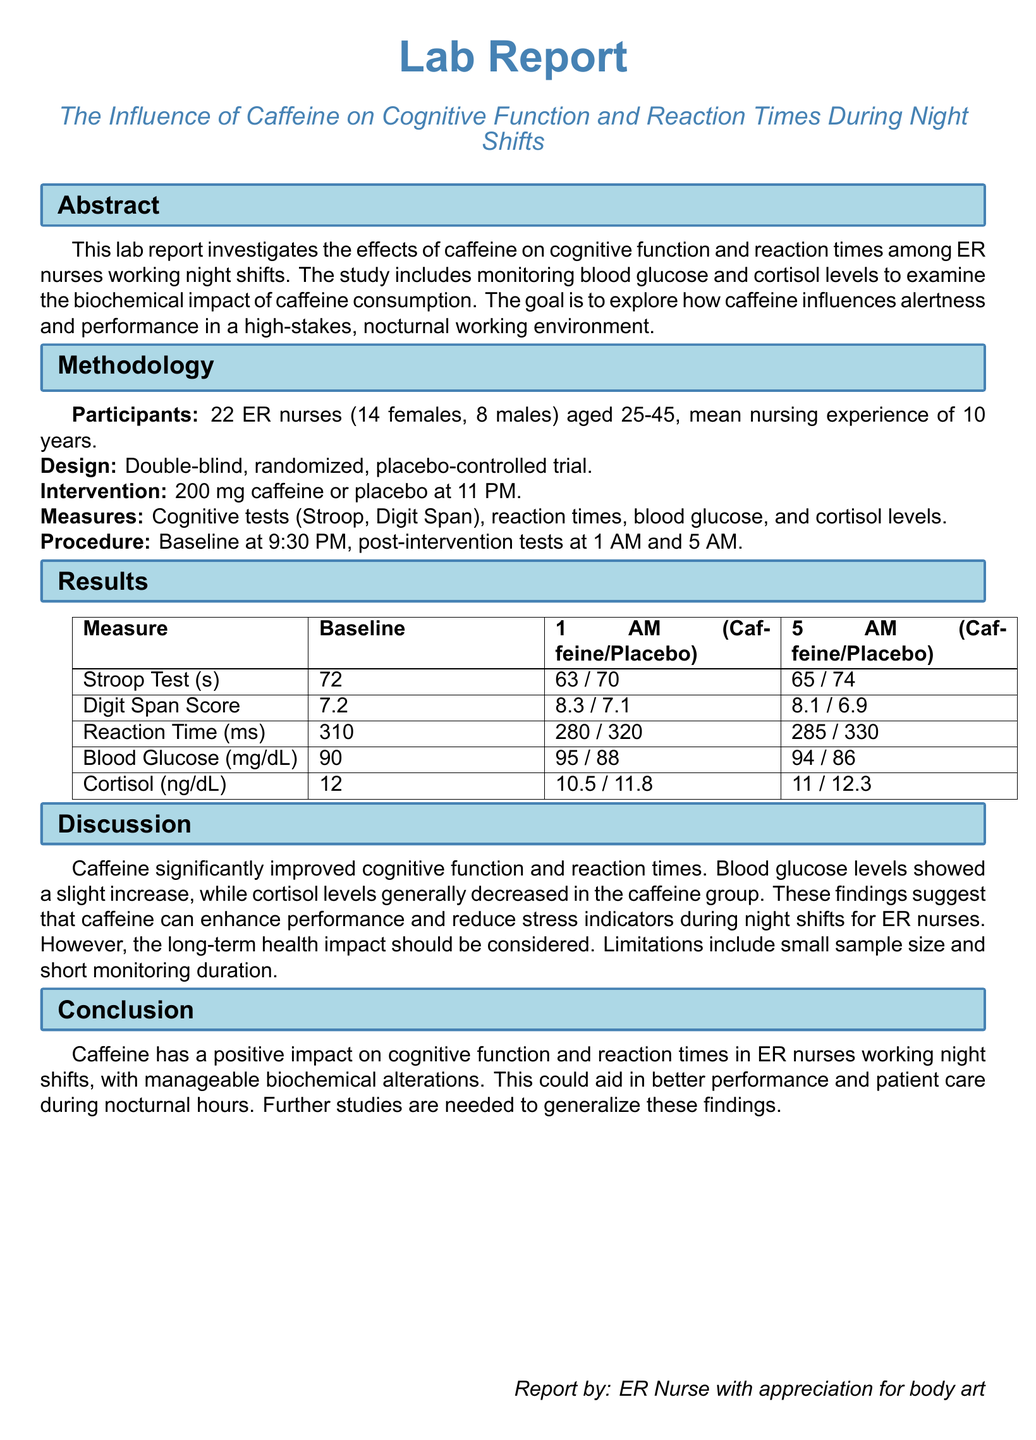what was the sample size of the study? The document states that the study included 22 ER nurses.
Answer: 22 what was the age range of participants? The age range of participants is provided as 25-45 years.
Answer: 25-45 what was the caffeine dosage administered in the intervention? The caffeine dosage given during the trial was specified as 200 mg.
Answer: 200 mg what is the mean nursing experience of participants? The report indicates that the mean nursing experience among participants was 10 years.
Answer: 10 years how did blood glucose levels change at 1 AM for the caffeine group? Blood glucose levels were measured at 95 mg/dL for the caffeine group at 1 AM.
Answer: 95 what was the effect of caffeine on reaction times at 5 AM? Reaction times for the caffeine group improved to 285 ms at 5 AM.
Answer: 285 ms which cognitive test had the highest baseline score? The baseline score for the Digit Span Score was the highest at 7.2.
Answer: Digit Span Score how many males participated in the study? The document mentions that there were 8 males among the participants.
Answer: 8 what does the conclusion suggest about caffeine's impact? The conclusion states that caffeine has a positive impact on cognitive function and reaction times.
Answer: positive impact what limitation is highlighted in the discussion? The discussion notes that a limitation is the small sample size of the study.
Answer: small sample size 